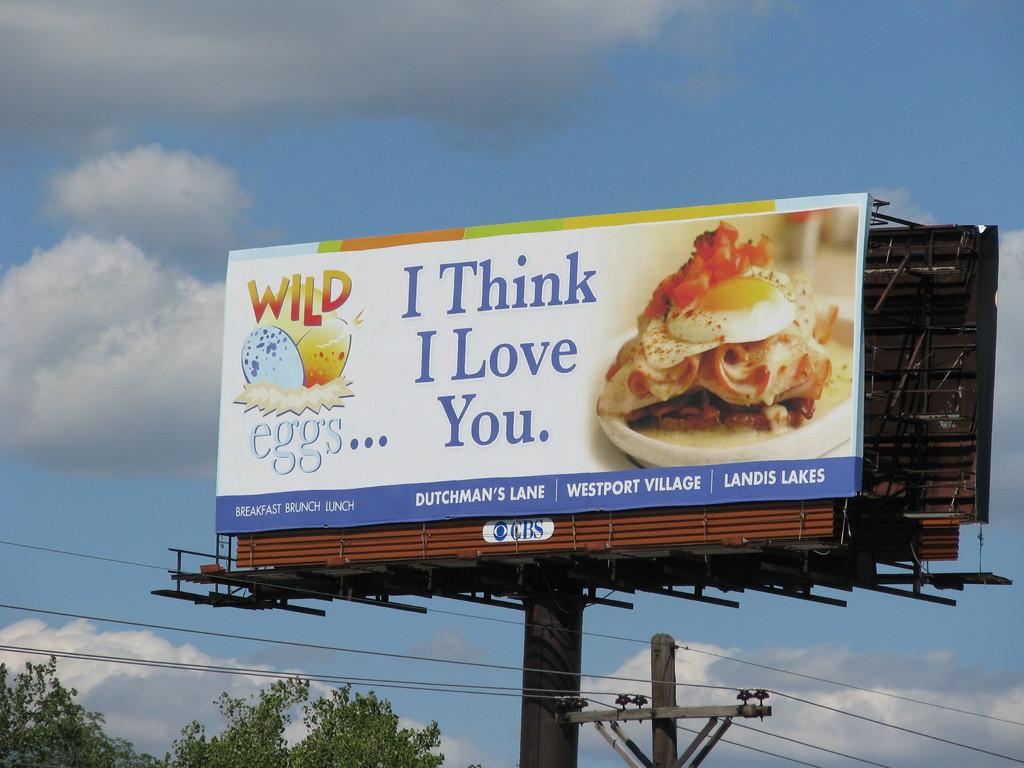What is loved?
Your answer should be compact. You. 